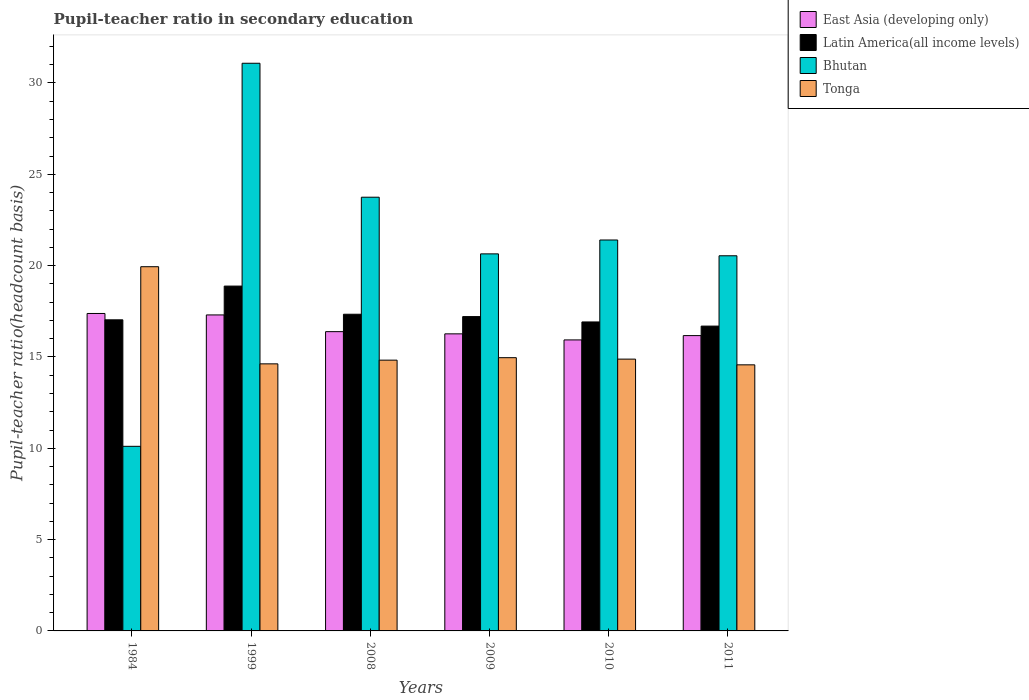How many different coloured bars are there?
Make the answer very short. 4. Are the number of bars on each tick of the X-axis equal?
Offer a terse response. Yes. What is the label of the 6th group of bars from the left?
Make the answer very short. 2011. In how many cases, is the number of bars for a given year not equal to the number of legend labels?
Your answer should be compact. 0. What is the pupil-teacher ratio in secondary education in Tonga in 1984?
Give a very brief answer. 19.94. Across all years, what is the maximum pupil-teacher ratio in secondary education in Latin America(all income levels)?
Ensure brevity in your answer.  18.88. Across all years, what is the minimum pupil-teacher ratio in secondary education in Bhutan?
Your answer should be very brief. 10.11. In which year was the pupil-teacher ratio in secondary education in Latin America(all income levels) maximum?
Offer a very short reply. 1999. What is the total pupil-teacher ratio in secondary education in Latin America(all income levels) in the graph?
Give a very brief answer. 104.07. What is the difference between the pupil-teacher ratio in secondary education in Tonga in 1984 and that in 1999?
Keep it short and to the point. 5.32. What is the difference between the pupil-teacher ratio in secondary education in Tonga in 2010 and the pupil-teacher ratio in secondary education in Latin America(all income levels) in 1999?
Keep it short and to the point. -4. What is the average pupil-teacher ratio in secondary education in Bhutan per year?
Your answer should be compact. 21.25. In the year 1984, what is the difference between the pupil-teacher ratio in secondary education in Bhutan and pupil-teacher ratio in secondary education in East Asia (developing only)?
Offer a terse response. -7.27. In how many years, is the pupil-teacher ratio in secondary education in Tonga greater than 6?
Your response must be concise. 6. What is the ratio of the pupil-teacher ratio in secondary education in East Asia (developing only) in 2009 to that in 2011?
Provide a succinct answer. 1.01. Is the pupil-teacher ratio in secondary education in Tonga in 2008 less than that in 2010?
Provide a short and direct response. Yes. What is the difference between the highest and the second highest pupil-teacher ratio in secondary education in Latin America(all income levels)?
Offer a very short reply. 1.54. What is the difference between the highest and the lowest pupil-teacher ratio in secondary education in Tonga?
Your response must be concise. 5.37. In how many years, is the pupil-teacher ratio in secondary education in East Asia (developing only) greater than the average pupil-teacher ratio in secondary education in East Asia (developing only) taken over all years?
Your response must be concise. 2. Is it the case that in every year, the sum of the pupil-teacher ratio in secondary education in East Asia (developing only) and pupil-teacher ratio in secondary education in Bhutan is greater than the sum of pupil-teacher ratio in secondary education in Tonga and pupil-teacher ratio in secondary education in Latin America(all income levels)?
Provide a short and direct response. No. What does the 4th bar from the left in 2009 represents?
Make the answer very short. Tonga. What does the 3rd bar from the right in 1984 represents?
Offer a very short reply. Latin America(all income levels). Is it the case that in every year, the sum of the pupil-teacher ratio in secondary education in Latin America(all income levels) and pupil-teacher ratio in secondary education in Tonga is greater than the pupil-teacher ratio in secondary education in East Asia (developing only)?
Ensure brevity in your answer.  Yes. Are all the bars in the graph horizontal?
Your response must be concise. No. What is the difference between two consecutive major ticks on the Y-axis?
Provide a short and direct response. 5. Does the graph contain any zero values?
Make the answer very short. No. Does the graph contain grids?
Your response must be concise. No. How many legend labels are there?
Make the answer very short. 4. How are the legend labels stacked?
Your answer should be compact. Vertical. What is the title of the graph?
Ensure brevity in your answer.  Pupil-teacher ratio in secondary education. What is the label or title of the Y-axis?
Ensure brevity in your answer.  Pupil-teacher ratio(headcount basis). What is the Pupil-teacher ratio(headcount basis) in East Asia (developing only) in 1984?
Ensure brevity in your answer.  17.38. What is the Pupil-teacher ratio(headcount basis) in Latin America(all income levels) in 1984?
Give a very brief answer. 17.03. What is the Pupil-teacher ratio(headcount basis) of Bhutan in 1984?
Provide a short and direct response. 10.11. What is the Pupil-teacher ratio(headcount basis) in Tonga in 1984?
Your answer should be very brief. 19.94. What is the Pupil-teacher ratio(headcount basis) of East Asia (developing only) in 1999?
Your answer should be very brief. 17.3. What is the Pupil-teacher ratio(headcount basis) of Latin America(all income levels) in 1999?
Make the answer very short. 18.88. What is the Pupil-teacher ratio(headcount basis) in Bhutan in 1999?
Give a very brief answer. 31.08. What is the Pupil-teacher ratio(headcount basis) of Tonga in 1999?
Offer a very short reply. 14.62. What is the Pupil-teacher ratio(headcount basis) of East Asia (developing only) in 2008?
Provide a succinct answer. 16.38. What is the Pupil-teacher ratio(headcount basis) of Latin America(all income levels) in 2008?
Provide a short and direct response. 17.34. What is the Pupil-teacher ratio(headcount basis) in Bhutan in 2008?
Keep it short and to the point. 23.75. What is the Pupil-teacher ratio(headcount basis) in Tonga in 2008?
Give a very brief answer. 14.82. What is the Pupil-teacher ratio(headcount basis) of East Asia (developing only) in 2009?
Provide a short and direct response. 16.26. What is the Pupil-teacher ratio(headcount basis) in Latin America(all income levels) in 2009?
Your answer should be very brief. 17.21. What is the Pupil-teacher ratio(headcount basis) of Bhutan in 2009?
Make the answer very short. 20.64. What is the Pupil-teacher ratio(headcount basis) in Tonga in 2009?
Make the answer very short. 14.96. What is the Pupil-teacher ratio(headcount basis) of East Asia (developing only) in 2010?
Provide a short and direct response. 15.93. What is the Pupil-teacher ratio(headcount basis) of Latin America(all income levels) in 2010?
Ensure brevity in your answer.  16.92. What is the Pupil-teacher ratio(headcount basis) in Bhutan in 2010?
Make the answer very short. 21.4. What is the Pupil-teacher ratio(headcount basis) of Tonga in 2010?
Give a very brief answer. 14.88. What is the Pupil-teacher ratio(headcount basis) of East Asia (developing only) in 2011?
Offer a very short reply. 16.17. What is the Pupil-teacher ratio(headcount basis) of Latin America(all income levels) in 2011?
Give a very brief answer. 16.69. What is the Pupil-teacher ratio(headcount basis) of Bhutan in 2011?
Provide a short and direct response. 20.54. What is the Pupil-teacher ratio(headcount basis) of Tonga in 2011?
Keep it short and to the point. 14.57. Across all years, what is the maximum Pupil-teacher ratio(headcount basis) in East Asia (developing only)?
Make the answer very short. 17.38. Across all years, what is the maximum Pupil-teacher ratio(headcount basis) of Latin America(all income levels)?
Keep it short and to the point. 18.88. Across all years, what is the maximum Pupil-teacher ratio(headcount basis) in Bhutan?
Offer a very short reply. 31.08. Across all years, what is the maximum Pupil-teacher ratio(headcount basis) in Tonga?
Make the answer very short. 19.94. Across all years, what is the minimum Pupil-teacher ratio(headcount basis) of East Asia (developing only)?
Your response must be concise. 15.93. Across all years, what is the minimum Pupil-teacher ratio(headcount basis) in Latin America(all income levels)?
Your answer should be very brief. 16.69. Across all years, what is the minimum Pupil-teacher ratio(headcount basis) in Bhutan?
Give a very brief answer. 10.11. Across all years, what is the minimum Pupil-teacher ratio(headcount basis) of Tonga?
Provide a short and direct response. 14.57. What is the total Pupil-teacher ratio(headcount basis) of East Asia (developing only) in the graph?
Offer a very short reply. 99.43. What is the total Pupil-teacher ratio(headcount basis) in Latin America(all income levels) in the graph?
Your response must be concise. 104.07. What is the total Pupil-teacher ratio(headcount basis) of Bhutan in the graph?
Ensure brevity in your answer.  127.52. What is the total Pupil-teacher ratio(headcount basis) in Tonga in the graph?
Provide a succinct answer. 93.8. What is the difference between the Pupil-teacher ratio(headcount basis) in East Asia (developing only) in 1984 and that in 1999?
Offer a terse response. 0.08. What is the difference between the Pupil-teacher ratio(headcount basis) in Latin America(all income levels) in 1984 and that in 1999?
Your response must be concise. -1.85. What is the difference between the Pupil-teacher ratio(headcount basis) of Bhutan in 1984 and that in 1999?
Your answer should be very brief. -20.97. What is the difference between the Pupil-teacher ratio(headcount basis) of Tonga in 1984 and that in 1999?
Offer a terse response. 5.32. What is the difference between the Pupil-teacher ratio(headcount basis) of East Asia (developing only) in 1984 and that in 2008?
Ensure brevity in your answer.  1. What is the difference between the Pupil-teacher ratio(headcount basis) of Latin America(all income levels) in 1984 and that in 2008?
Your answer should be compact. -0.31. What is the difference between the Pupil-teacher ratio(headcount basis) of Bhutan in 1984 and that in 2008?
Give a very brief answer. -13.64. What is the difference between the Pupil-teacher ratio(headcount basis) in Tonga in 1984 and that in 2008?
Provide a succinct answer. 5.12. What is the difference between the Pupil-teacher ratio(headcount basis) in East Asia (developing only) in 1984 and that in 2009?
Offer a terse response. 1.12. What is the difference between the Pupil-teacher ratio(headcount basis) in Latin America(all income levels) in 1984 and that in 2009?
Your response must be concise. -0.18. What is the difference between the Pupil-teacher ratio(headcount basis) in Bhutan in 1984 and that in 2009?
Your response must be concise. -10.54. What is the difference between the Pupil-teacher ratio(headcount basis) of Tonga in 1984 and that in 2009?
Offer a very short reply. 4.98. What is the difference between the Pupil-teacher ratio(headcount basis) in East Asia (developing only) in 1984 and that in 2010?
Provide a short and direct response. 1.45. What is the difference between the Pupil-teacher ratio(headcount basis) of Latin America(all income levels) in 1984 and that in 2010?
Keep it short and to the point. 0.12. What is the difference between the Pupil-teacher ratio(headcount basis) in Bhutan in 1984 and that in 2010?
Your answer should be very brief. -11.3. What is the difference between the Pupil-teacher ratio(headcount basis) of Tonga in 1984 and that in 2010?
Provide a succinct answer. 5.06. What is the difference between the Pupil-teacher ratio(headcount basis) of East Asia (developing only) in 1984 and that in 2011?
Provide a succinct answer. 1.21. What is the difference between the Pupil-teacher ratio(headcount basis) in Latin America(all income levels) in 1984 and that in 2011?
Provide a short and direct response. 0.34. What is the difference between the Pupil-teacher ratio(headcount basis) of Bhutan in 1984 and that in 2011?
Give a very brief answer. -10.43. What is the difference between the Pupil-teacher ratio(headcount basis) of Tonga in 1984 and that in 2011?
Give a very brief answer. 5.37. What is the difference between the Pupil-teacher ratio(headcount basis) of East Asia (developing only) in 1999 and that in 2008?
Offer a terse response. 0.92. What is the difference between the Pupil-teacher ratio(headcount basis) of Latin America(all income levels) in 1999 and that in 2008?
Provide a succinct answer. 1.54. What is the difference between the Pupil-teacher ratio(headcount basis) of Bhutan in 1999 and that in 2008?
Provide a succinct answer. 7.33. What is the difference between the Pupil-teacher ratio(headcount basis) of Tonga in 1999 and that in 2008?
Your answer should be very brief. -0.2. What is the difference between the Pupil-teacher ratio(headcount basis) in East Asia (developing only) in 1999 and that in 2009?
Give a very brief answer. 1.04. What is the difference between the Pupil-teacher ratio(headcount basis) of Latin America(all income levels) in 1999 and that in 2009?
Give a very brief answer. 1.67. What is the difference between the Pupil-teacher ratio(headcount basis) of Bhutan in 1999 and that in 2009?
Ensure brevity in your answer.  10.44. What is the difference between the Pupil-teacher ratio(headcount basis) in Tonga in 1999 and that in 2009?
Offer a terse response. -0.34. What is the difference between the Pupil-teacher ratio(headcount basis) in East Asia (developing only) in 1999 and that in 2010?
Keep it short and to the point. 1.37. What is the difference between the Pupil-teacher ratio(headcount basis) of Latin America(all income levels) in 1999 and that in 2010?
Offer a very short reply. 1.96. What is the difference between the Pupil-teacher ratio(headcount basis) of Bhutan in 1999 and that in 2010?
Your answer should be compact. 9.68. What is the difference between the Pupil-teacher ratio(headcount basis) of Tonga in 1999 and that in 2010?
Your answer should be compact. -0.26. What is the difference between the Pupil-teacher ratio(headcount basis) of East Asia (developing only) in 1999 and that in 2011?
Your answer should be very brief. 1.13. What is the difference between the Pupil-teacher ratio(headcount basis) in Latin America(all income levels) in 1999 and that in 2011?
Provide a short and direct response. 2.19. What is the difference between the Pupil-teacher ratio(headcount basis) in Bhutan in 1999 and that in 2011?
Make the answer very short. 10.54. What is the difference between the Pupil-teacher ratio(headcount basis) of Tonga in 1999 and that in 2011?
Offer a terse response. 0.05. What is the difference between the Pupil-teacher ratio(headcount basis) of East Asia (developing only) in 2008 and that in 2009?
Your answer should be very brief. 0.12. What is the difference between the Pupil-teacher ratio(headcount basis) of Latin America(all income levels) in 2008 and that in 2009?
Give a very brief answer. 0.13. What is the difference between the Pupil-teacher ratio(headcount basis) of Bhutan in 2008 and that in 2009?
Give a very brief answer. 3.1. What is the difference between the Pupil-teacher ratio(headcount basis) of Tonga in 2008 and that in 2009?
Make the answer very short. -0.14. What is the difference between the Pupil-teacher ratio(headcount basis) of East Asia (developing only) in 2008 and that in 2010?
Keep it short and to the point. 0.45. What is the difference between the Pupil-teacher ratio(headcount basis) in Latin America(all income levels) in 2008 and that in 2010?
Keep it short and to the point. 0.42. What is the difference between the Pupil-teacher ratio(headcount basis) of Bhutan in 2008 and that in 2010?
Your response must be concise. 2.34. What is the difference between the Pupil-teacher ratio(headcount basis) of Tonga in 2008 and that in 2010?
Offer a terse response. -0.06. What is the difference between the Pupil-teacher ratio(headcount basis) in East Asia (developing only) in 2008 and that in 2011?
Provide a succinct answer. 0.22. What is the difference between the Pupil-teacher ratio(headcount basis) of Latin America(all income levels) in 2008 and that in 2011?
Provide a short and direct response. 0.65. What is the difference between the Pupil-teacher ratio(headcount basis) in Bhutan in 2008 and that in 2011?
Your answer should be compact. 3.21. What is the difference between the Pupil-teacher ratio(headcount basis) of Tonga in 2008 and that in 2011?
Offer a terse response. 0.26. What is the difference between the Pupil-teacher ratio(headcount basis) in East Asia (developing only) in 2009 and that in 2010?
Ensure brevity in your answer.  0.33. What is the difference between the Pupil-teacher ratio(headcount basis) in Latin America(all income levels) in 2009 and that in 2010?
Ensure brevity in your answer.  0.29. What is the difference between the Pupil-teacher ratio(headcount basis) of Bhutan in 2009 and that in 2010?
Provide a succinct answer. -0.76. What is the difference between the Pupil-teacher ratio(headcount basis) of Tonga in 2009 and that in 2010?
Offer a terse response. 0.08. What is the difference between the Pupil-teacher ratio(headcount basis) in East Asia (developing only) in 2009 and that in 2011?
Your response must be concise. 0.1. What is the difference between the Pupil-teacher ratio(headcount basis) in Latin America(all income levels) in 2009 and that in 2011?
Make the answer very short. 0.52. What is the difference between the Pupil-teacher ratio(headcount basis) in Bhutan in 2009 and that in 2011?
Your answer should be compact. 0.1. What is the difference between the Pupil-teacher ratio(headcount basis) of Tonga in 2009 and that in 2011?
Ensure brevity in your answer.  0.39. What is the difference between the Pupil-teacher ratio(headcount basis) of East Asia (developing only) in 2010 and that in 2011?
Give a very brief answer. -0.24. What is the difference between the Pupil-teacher ratio(headcount basis) in Latin America(all income levels) in 2010 and that in 2011?
Ensure brevity in your answer.  0.23. What is the difference between the Pupil-teacher ratio(headcount basis) in Bhutan in 2010 and that in 2011?
Offer a very short reply. 0.86. What is the difference between the Pupil-teacher ratio(headcount basis) of Tonga in 2010 and that in 2011?
Provide a succinct answer. 0.31. What is the difference between the Pupil-teacher ratio(headcount basis) in East Asia (developing only) in 1984 and the Pupil-teacher ratio(headcount basis) in Latin America(all income levels) in 1999?
Offer a very short reply. -1.5. What is the difference between the Pupil-teacher ratio(headcount basis) of East Asia (developing only) in 1984 and the Pupil-teacher ratio(headcount basis) of Bhutan in 1999?
Offer a very short reply. -13.7. What is the difference between the Pupil-teacher ratio(headcount basis) of East Asia (developing only) in 1984 and the Pupil-teacher ratio(headcount basis) of Tonga in 1999?
Your answer should be very brief. 2.76. What is the difference between the Pupil-teacher ratio(headcount basis) of Latin America(all income levels) in 1984 and the Pupil-teacher ratio(headcount basis) of Bhutan in 1999?
Offer a very short reply. -14.05. What is the difference between the Pupil-teacher ratio(headcount basis) in Latin America(all income levels) in 1984 and the Pupil-teacher ratio(headcount basis) in Tonga in 1999?
Make the answer very short. 2.41. What is the difference between the Pupil-teacher ratio(headcount basis) of Bhutan in 1984 and the Pupil-teacher ratio(headcount basis) of Tonga in 1999?
Keep it short and to the point. -4.52. What is the difference between the Pupil-teacher ratio(headcount basis) in East Asia (developing only) in 1984 and the Pupil-teacher ratio(headcount basis) in Latin America(all income levels) in 2008?
Your answer should be compact. 0.04. What is the difference between the Pupil-teacher ratio(headcount basis) in East Asia (developing only) in 1984 and the Pupil-teacher ratio(headcount basis) in Bhutan in 2008?
Ensure brevity in your answer.  -6.37. What is the difference between the Pupil-teacher ratio(headcount basis) in East Asia (developing only) in 1984 and the Pupil-teacher ratio(headcount basis) in Tonga in 2008?
Your answer should be compact. 2.56. What is the difference between the Pupil-teacher ratio(headcount basis) of Latin America(all income levels) in 1984 and the Pupil-teacher ratio(headcount basis) of Bhutan in 2008?
Your answer should be very brief. -6.71. What is the difference between the Pupil-teacher ratio(headcount basis) in Latin America(all income levels) in 1984 and the Pupil-teacher ratio(headcount basis) in Tonga in 2008?
Keep it short and to the point. 2.21. What is the difference between the Pupil-teacher ratio(headcount basis) of Bhutan in 1984 and the Pupil-teacher ratio(headcount basis) of Tonga in 2008?
Offer a terse response. -4.72. What is the difference between the Pupil-teacher ratio(headcount basis) of East Asia (developing only) in 1984 and the Pupil-teacher ratio(headcount basis) of Latin America(all income levels) in 2009?
Your response must be concise. 0.17. What is the difference between the Pupil-teacher ratio(headcount basis) in East Asia (developing only) in 1984 and the Pupil-teacher ratio(headcount basis) in Bhutan in 2009?
Offer a terse response. -3.26. What is the difference between the Pupil-teacher ratio(headcount basis) of East Asia (developing only) in 1984 and the Pupil-teacher ratio(headcount basis) of Tonga in 2009?
Ensure brevity in your answer.  2.42. What is the difference between the Pupil-teacher ratio(headcount basis) in Latin America(all income levels) in 1984 and the Pupil-teacher ratio(headcount basis) in Bhutan in 2009?
Your response must be concise. -3.61. What is the difference between the Pupil-teacher ratio(headcount basis) in Latin America(all income levels) in 1984 and the Pupil-teacher ratio(headcount basis) in Tonga in 2009?
Make the answer very short. 2.07. What is the difference between the Pupil-teacher ratio(headcount basis) of Bhutan in 1984 and the Pupil-teacher ratio(headcount basis) of Tonga in 2009?
Provide a short and direct response. -4.85. What is the difference between the Pupil-teacher ratio(headcount basis) of East Asia (developing only) in 1984 and the Pupil-teacher ratio(headcount basis) of Latin America(all income levels) in 2010?
Give a very brief answer. 0.46. What is the difference between the Pupil-teacher ratio(headcount basis) of East Asia (developing only) in 1984 and the Pupil-teacher ratio(headcount basis) of Bhutan in 2010?
Give a very brief answer. -4.02. What is the difference between the Pupil-teacher ratio(headcount basis) of East Asia (developing only) in 1984 and the Pupil-teacher ratio(headcount basis) of Tonga in 2010?
Make the answer very short. 2.5. What is the difference between the Pupil-teacher ratio(headcount basis) in Latin America(all income levels) in 1984 and the Pupil-teacher ratio(headcount basis) in Bhutan in 2010?
Provide a short and direct response. -4.37. What is the difference between the Pupil-teacher ratio(headcount basis) of Latin America(all income levels) in 1984 and the Pupil-teacher ratio(headcount basis) of Tonga in 2010?
Offer a terse response. 2.15. What is the difference between the Pupil-teacher ratio(headcount basis) in Bhutan in 1984 and the Pupil-teacher ratio(headcount basis) in Tonga in 2010?
Ensure brevity in your answer.  -4.77. What is the difference between the Pupil-teacher ratio(headcount basis) in East Asia (developing only) in 1984 and the Pupil-teacher ratio(headcount basis) in Latin America(all income levels) in 2011?
Your answer should be compact. 0.69. What is the difference between the Pupil-teacher ratio(headcount basis) in East Asia (developing only) in 1984 and the Pupil-teacher ratio(headcount basis) in Bhutan in 2011?
Give a very brief answer. -3.16. What is the difference between the Pupil-teacher ratio(headcount basis) of East Asia (developing only) in 1984 and the Pupil-teacher ratio(headcount basis) of Tonga in 2011?
Offer a very short reply. 2.81. What is the difference between the Pupil-teacher ratio(headcount basis) of Latin America(all income levels) in 1984 and the Pupil-teacher ratio(headcount basis) of Bhutan in 2011?
Offer a terse response. -3.51. What is the difference between the Pupil-teacher ratio(headcount basis) in Latin America(all income levels) in 1984 and the Pupil-teacher ratio(headcount basis) in Tonga in 2011?
Offer a terse response. 2.46. What is the difference between the Pupil-teacher ratio(headcount basis) of Bhutan in 1984 and the Pupil-teacher ratio(headcount basis) of Tonga in 2011?
Your answer should be very brief. -4.46. What is the difference between the Pupil-teacher ratio(headcount basis) in East Asia (developing only) in 1999 and the Pupil-teacher ratio(headcount basis) in Latin America(all income levels) in 2008?
Give a very brief answer. -0.04. What is the difference between the Pupil-teacher ratio(headcount basis) in East Asia (developing only) in 1999 and the Pupil-teacher ratio(headcount basis) in Bhutan in 2008?
Give a very brief answer. -6.45. What is the difference between the Pupil-teacher ratio(headcount basis) in East Asia (developing only) in 1999 and the Pupil-teacher ratio(headcount basis) in Tonga in 2008?
Offer a terse response. 2.48. What is the difference between the Pupil-teacher ratio(headcount basis) in Latin America(all income levels) in 1999 and the Pupil-teacher ratio(headcount basis) in Bhutan in 2008?
Give a very brief answer. -4.87. What is the difference between the Pupil-teacher ratio(headcount basis) in Latin America(all income levels) in 1999 and the Pupil-teacher ratio(headcount basis) in Tonga in 2008?
Make the answer very short. 4.05. What is the difference between the Pupil-teacher ratio(headcount basis) in Bhutan in 1999 and the Pupil-teacher ratio(headcount basis) in Tonga in 2008?
Offer a terse response. 16.25. What is the difference between the Pupil-teacher ratio(headcount basis) of East Asia (developing only) in 1999 and the Pupil-teacher ratio(headcount basis) of Latin America(all income levels) in 2009?
Keep it short and to the point. 0.09. What is the difference between the Pupil-teacher ratio(headcount basis) in East Asia (developing only) in 1999 and the Pupil-teacher ratio(headcount basis) in Bhutan in 2009?
Your answer should be very brief. -3.34. What is the difference between the Pupil-teacher ratio(headcount basis) of East Asia (developing only) in 1999 and the Pupil-teacher ratio(headcount basis) of Tonga in 2009?
Ensure brevity in your answer.  2.34. What is the difference between the Pupil-teacher ratio(headcount basis) of Latin America(all income levels) in 1999 and the Pupil-teacher ratio(headcount basis) of Bhutan in 2009?
Provide a succinct answer. -1.76. What is the difference between the Pupil-teacher ratio(headcount basis) in Latin America(all income levels) in 1999 and the Pupil-teacher ratio(headcount basis) in Tonga in 2009?
Your response must be concise. 3.92. What is the difference between the Pupil-teacher ratio(headcount basis) of Bhutan in 1999 and the Pupil-teacher ratio(headcount basis) of Tonga in 2009?
Offer a very short reply. 16.12. What is the difference between the Pupil-teacher ratio(headcount basis) of East Asia (developing only) in 1999 and the Pupil-teacher ratio(headcount basis) of Latin America(all income levels) in 2010?
Give a very brief answer. 0.38. What is the difference between the Pupil-teacher ratio(headcount basis) of East Asia (developing only) in 1999 and the Pupil-teacher ratio(headcount basis) of Bhutan in 2010?
Give a very brief answer. -4.1. What is the difference between the Pupil-teacher ratio(headcount basis) in East Asia (developing only) in 1999 and the Pupil-teacher ratio(headcount basis) in Tonga in 2010?
Provide a short and direct response. 2.42. What is the difference between the Pupil-teacher ratio(headcount basis) of Latin America(all income levels) in 1999 and the Pupil-teacher ratio(headcount basis) of Bhutan in 2010?
Provide a short and direct response. -2.52. What is the difference between the Pupil-teacher ratio(headcount basis) of Latin America(all income levels) in 1999 and the Pupil-teacher ratio(headcount basis) of Tonga in 2010?
Ensure brevity in your answer.  4. What is the difference between the Pupil-teacher ratio(headcount basis) in Bhutan in 1999 and the Pupil-teacher ratio(headcount basis) in Tonga in 2010?
Provide a short and direct response. 16.2. What is the difference between the Pupil-teacher ratio(headcount basis) of East Asia (developing only) in 1999 and the Pupil-teacher ratio(headcount basis) of Latin America(all income levels) in 2011?
Keep it short and to the point. 0.61. What is the difference between the Pupil-teacher ratio(headcount basis) in East Asia (developing only) in 1999 and the Pupil-teacher ratio(headcount basis) in Bhutan in 2011?
Offer a very short reply. -3.24. What is the difference between the Pupil-teacher ratio(headcount basis) of East Asia (developing only) in 1999 and the Pupil-teacher ratio(headcount basis) of Tonga in 2011?
Offer a terse response. 2.73. What is the difference between the Pupil-teacher ratio(headcount basis) in Latin America(all income levels) in 1999 and the Pupil-teacher ratio(headcount basis) in Bhutan in 2011?
Make the answer very short. -1.66. What is the difference between the Pupil-teacher ratio(headcount basis) of Latin America(all income levels) in 1999 and the Pupil-teacher ratio(headcount basis) of Tonga in 2011?
Your answer should be very brief. 4.31. What is the difference between the Pupil-teacher ratio(headcount basis) in Bhutan in 1999 and the Pupil-teacher ratio(headcount basis) in Tonga in 2011?
Your answer should be very brief. 16.51. What is the difference between the Pupil-teacher ratio(headcount basis) in East Asia (developing only) in 2008 and the Pupil-teacher ratio(headcount basis) in Latin America(all income levels) in 2009?
Offer a terse response. -0.82. What is the difference between the Pupil-teacher ratio(headcount basis) in East Asia (developing only) in 2008 and the Pupil-teacher ratio(headcount basis) in Bhutan in 2009?
Your response must be concise. -4.26. What is the difference between the Pupil-teacher ratio(headcount basis) in East Asia (developing only) in 2008 and the Pupil-teacher ratio(headcount basis) in Tonga in 2009?
Your answer should be compact. 1.42. What is the difference between the Pupil-teacher ratio(headcount basis) in Latin America(all income levels) in 2008 and the Pupil-teacher ratio(headcount basis) in Bhutan in 2009?
Give a very brief answer. -3.31. What is the difference between the Pupil-teacher ratio(headcount basis) of Latin America(all income levels) in 2008 and the Pupil-teacher ratio(headcount basis) of Tonga in 2009?
Make the answer very short. 2.38. What is the difference between the Pupil-teacher ratio(headcount basis) in Bhutan in 2008 and the Pupil-teacher ratio(headcount basis) in Tonga in 2009?
Your answer should be compact. 8.79. What is the difference between the Pupil-teacher ratio(headcount basis) in East Asia (developing only) in 2008 and the Pupil-teacher ratio(headcount basis) in Latin America(all income levels) in 2010?
Your response must be concise. -0.53. What is the difference between the Pupil-teacher ratio(headcount basis) in East Asia (developing only) in 2008 and the Pupil-teacher ratio(headcount basis) in Bhutan in 2010?
Your answer should be very brief. -5.02. What is the difference between the Pupil-teacher ratio(headcount basis) of East Asia (developing only) in 2008 and the Pupil-teacher ratio(headcount basis) of Tonga in 2010?
Ensure brevity in your answer.  1.5. What is the difference between the Pupil-teacher ratio(headcount basis) of Latin America(all income levels) in 2008 and the Pupil-teacher ratio(headcount basis) of Bhutan in 2010?
Your answer should be compact. -4.07. What is the difference between the Pupil-teacher ratio(headcount basis) of Latin America(all income levels) in 2008 and the Pupil-teacher ratio(headcount basis) of Tonga in 2010?
Keep it short and to the point. 2.46. What is the difference between the Pupil-teacher ratio(headcount basis) of Bhutan in 2008 and the Pupil-teacher ratio(headcount basis) of Tonga in 2010?
Provide a short and direct response. 8.86. What is the difference between the Pupil-teacher ratio(headcount basis) of East Asia (developing only) in 2008 and the Pupil-teacher ratio(headcount basis) of Latin America(all income levels) in 2011?
Offer a terse response. -0.3. What is the difference between the Pupil-teacher ratio(headcount basis) of East Asia (developing only) in 2008 and the Pupil-teacher ratio(headcount basis) of Bhutan in 2011?
Keep it short and to the point. -4.15. What is the difference between the Pupil-teacher ratio(headcount basis) of East Asia (developing only) in 2008 and the Pupil-teacher ratio(headcount basis) of Tonga in 2011?
Offer a very short reply. 1.82. What is the difference between the Pupil-teacher ratio(headcount basis) of Latin America(all income levels) in 2008 and the Pupil-teacher ratio(headcount basis) of Bhutan in 2011?
Your response must be concise. -3.2. What is the difference between the Pupil-teacher ratio(headcount basis) of Latin America(all income levels) in 2008 and the Pupil-teacher ratio(headcount basis) of Tonga in 2011?
Give a very brief answer. 2.77. What is the difference between the Pupil-teacher ratio(headcount basis) of Bhutan in 2008 and the Pupil-teacher ratio(headcount basis) of Tonga in 2011?
Your answer should be compact. 9.18. What is the difference between the Pupil-teacher ratio(headcount basis) in East Asia (developing only) in 2009 and the Pupil-teacher ratio(headcount basis) in Latin America(all income levels) in 2010?
Give a very brief answer. -0.65. What is the difference between the Pupil-teacher ratio(headcount basis) in East Asia (developing only) in 2009 and the Pupil-teacher ratio(headcount basis) in Bhutan in 2010?
Your response must be concise. -5.14. What is the difference between the Pupil-teacher ratio(headcount basis) of East Asia (developing only) in 2009 and the Pupil-teacher ratio(headcount basis) of Tonga in 2010?
Your answer should be very brief. 1.38. What is the difference between the Pupil-teacher ratio(headcount basis) of Latin America(all income levels) in 2009 and the Pupil-teacher ratio(headcount basis) of Bhutan in 2010?
Provide a succinct answer. -4.19. What is the difference between the Pupil-teacher ratio(headcount basis) of Latin America(all income levels) in 2009 and the Pupil-teacher ratio(headcount basis) of Tonga in 2010?
Offer a terse response. 2.33. What is the difference between the Pupil-teacher ratio(headcount basis) of Bhutan in 2009 and the Pupil-teacher ratio(headcount basis) of Tonga in 2010?
Provide a short and direct response. 5.76. What is the difference between the Pupil-teacher ratio(headcount basis) in East Asia (developing only) in 2009 and the Pupil-teacher ratio(headcount basis) in Latin America(all income levels) in 2011?
Offer a very short reply. -0.42. What is the difference between the Pupil-teacher ratio(headcount basis) of East Asia (developing only) in 2009 and the Pupil-teacher ratio(headcount basis) of Bhutan in 2011?
Keep it short and to the point. -4.27. What is the difference between the Pupil-teacher ratio(headcount basis) in East Asia (developing only) in 2009 and the Pupil-teacher ratio(headcount basis) in Tonga in 2011?
Provide a short and direct response. 1.7. What is the difference between the Pupil-teacher ratio(headcount basis) of Latin America(all income levels) in 2009 and the Pupil-teacher ratio(headcount basis) of Bhutan in 2011?
Offer a terse response. -3.33. What is the difference between the Pupil-teacher ratio(headcount basis) in Latin America(all income levels) in 2009 and the Pupil-teacher ratio(headcount basis) in Tonga in 2011?
Give a very brief answer. 2.64. What is the difference between the Pupil-teacher ratio(headcount basis) in Bhutan in 2009 and the Pupil-teacher ratio(headcount basis) in Tonga in 2011?
Ensure brevity in your answer.  6.08. What is the difference between the Pupil-teacher ratio(headcount basis) of East Asia (developing only) in 2010 and the Pupil-teacher ratio(headcount basis) of Latin America(all income levels) in 2011?
Give a very brief answer. -0.76. What is the difference between the Pupil-teacher ratio(headcount basis) of East Asia (developing only) in 2010 and the Pupil-teacher ratio(headcount basis) of Bhutan in 2011?
Make the answer very short. -4.61. What is the difference between the Pupil-teacher ratio(headcount basis) in East Asia (developing only) in 2010 and the Pupil-teacher ratio(headcount basis) in Tonga in 2011?
Keep it short and to the point. 1.36. What is the difference between the Pupil-teacher ratio(headcount basis) of Latin America(all income levels) in 2010 and the Pupil-teacher ratio(headcount basis) of Bhutan in 2011?
Your response must be concise. -3.62. What is the difference between the Pupil-teacher ratio(headcount basis) of Latin America(all income levels) in 2010 and the Pupil-teacher ratio(headcount basis) of Tonga in 2011?
Keep it short and to the point. 2.35. What is the difference between the Pupil-teacher ratio(headcount basis) of Bhutan in 2010 and the Pupil-teacher ratio(headcount basis) of Tonga in 2011?
Your answer should be compact. 6.84. What is the average Pupil-teacher ratio(headcount basis) in East Asia (developing only) per year?
Offer a terse response. 16.57. What is the average Pupil-teacher ratio(headcount basis) of Latin America(all income levels) per year?
Keep it short and to the point. 17.34. What is the average Pupil-teacher ratio(headcount basis) of Bhutan per year?
Provide a succinct answer. 21.25. What is the average Pupil-teacher ratio(headcount basis) of Tonga per year?
Keep it short and to the point. 15.63. In the year 1984, what is the difference between the Pupil-teacher ratio(headcount basis) of East Asia (developing only) and Pupil-teacher ratio(headcount basis) of Latin America(all income levels)?
Your answer should be very brief. 0.35. In the year 1984, what is the difference between the Pupil-teacher ratio(headcount basis) in East Asia (developing only) and Pupil-teacher ratio(headcount basis) in Bhutan?
Make the answer very short. 7.27. In the year 1984, what is the difference between the Pupil-teacher ratio(headcount basis) of East Asia (developing only) and Pupil-teacher ratio(headcount basis) of Tonga?
Provide a succinct answer. -2.56. In the year 1984, what is the difference between the Pupil-teacher ratio(headcount basis) of Latin America(all income levels) and Pupil-teacher ratio(headcount basis) of Bhutan?
Provide a short and direct response. 6.93. In the year 1984, what is the difference between the Pupil-teacher ratio(headcount basis) of Latin America(all income levels) and Pupil-teacher ratio(headcount basis) of Tonga?
Provide a short and direct response. -2.91. In the year 1984, what is the difference between the Pupil-teacher ratio(headcount basis) in Bhutan and Pupil-teacher ratio(headcount basis) in Tonga?
Keep it short and to the point. -9.83. In the year 1999, what is the difference between the Pupil-teacher ratio(headcount basis) in East Asia (developing only) and Pupil-teacher ratio(headcount basis) in Latin America(all income levels)?
Provide a short and direct response. -1.58. In the year 1999, what is the difference between the Pupil-teacher ratio(headcount basis) in East Asia (developing only) and Pupil-teacher ratio(headcount basis) in Bhutan?
Provide a succinct answer. -13.78. In the year 1999, what is the difference between the Pupil-teacher ratio(headcount basis) in East Asia (developing only) and Pupil-teacher ratio(headcount basis) in Tonga?
Provide a succinct answer. 2.68. In the year 1999, what is the difference between the Pupil-teacher ratio(headcount basis) of Latin America(all income levels) and Pupil-teacher ratio(headcount basis) of Bhutan?
Make the answer very short. -12.2. In the year 1999, what is the difference between the Pupil-teacher ratio(headcount basis) of Latin America(all income levels) and Pupil-teacher ratio(headcount basis) of Tonga?
Give a very brief answer. 4.26. In the year 1999, what is the difference between the Pupil-teacher ratio(headcount basis) of Bhutan and Pupil-teacher ratio(headcount basis) of Tonga?
Provide a succinct answer. 16.46. In the year 2008, what is the difference between the Pupil-teacher ratio(headcount basis) in East Asia (developing only) and Pupil-teacher ratio(headcount basis) in Latin America(all income levels)?
Your answer should be compact. -0.95. In the year 2008, what is the difference between the Pupil-teacher ratio(headcount basis) in East Asia (developing only) and Pupil-teacher ratio(headcount basis) in Bhutan?
Ensure brevity in your answer.  -7.36. In the year 2008, what is the difference between the Pupil-teacher ratio(headcount basis) in East Asia (developing only) and Pupil-teacher ratio(headcount basis) in Tonga?
Give a very brief answer. 1.56. In the year 2008, what is the difference between the Pupil-teacher ratio(headcount basis) in Latin America(all income levels) and Pupil-teacher ratio(headcount basis) in Bhutan?
Your answer should be very brief. -6.41. In the year 2008, what is the difference between the Pupil-teacher ratio(headcount basis) in Latin America(all income levels) and Pupil-teacher ratio(headcount basis) in Tonga?
Keep it short and to the point. 2.51. In the year 2008, what is the difference between the Pupil-teacher ratio(headcount basis) of Bhutan and Pupil-teacher ratio(headcount basis) of Tonga?
Your answer should be very brief. 8.92. In the year 2009, what is the difference between the Pupil-teacher ratio(headcount basis) in East Asia (developing only) and Pupil-teacher ratio(headcount basis) in Latin America(all income levels)?
Provide a succinct answer. -0.94. In the year 2009, what is the difference between the Pupil-teacher ratio(headcount basis) of East Asia (developing only) and Pupil-teacher ratio(headcount basis) of Bhutan?
Your answer should be very brief. -4.38. In the year 2009, what is the difference between the Pupil-teacher ratio(headcount basis) of East Asia (developing only) and Pupil-teacher ratio(headcount basis) of Tonga?
Provide a short and direct response. 1.3. In the year 2009, what is the difference between the Pupil-teacher ratio(headcount basis) of Latin America(all income levels) and Pupil-teacher ratio(headcount basis) of Bhutan?
Keep it short and to the point. -3.43. In the year 2009, what is the difference between the Pupil-teacher ratio(headcount basis) of Latin America(all income levels) and Pupil-teacher ratio(headcount basis) of Tonga?
Your response must be concise. 2.25. In the year 2009, what is the difference between the Pupil-teacher ratio(headcount basis) of Bhutan and Pupil-teacher ratio(headcount basis) of Tonga?
Offer a very short reply. 5.68. In the year 2010, what is the difference between the Pupil-teacher ratio(headcount basis) in East Asia (developing only) and Pupil-teacher ratio(headcount basis) in Latin America(all income levels)?
Your answer should be very brief. -0.98. In the year 2010, what is the difference between the Pupil-teacher ratio(headcount basis) of East Asia (developing only) and Pupil-teacher ratio(headcount basis) of Bhutan?
Make the answer very short. -5.47. In the year 2010, what is the difference between the Pupil-teacher ratio(headcount basis) of East Asia (developing only) and Pupil-teacher ratio(headcount basis) of Tonga?
Offer a terse response. 1.05. In the year 2010, what is the difference between the Pupil-teacher ratio(headcount basis) of Latin America(all income levels) and Pupil-teacher ratio(headcount basis) of Bhutan?
Offer a terse response. -4.49. In the year 2010, what is the difference between the Pupil-teacher ratio(headcount basis) of Latin America(all income levels) and Pupil-teacher ratio(headcount basis) of Tonga?
Keep it short and to the point. 2.04. In the year 2010, what is the difference between the Pupil-teacher ratio(headcount basis) of Bhutan and Pupil-teacher ratio(headcount basis) of Tonga?
Offer a very short reply. 6.52. In the year 2011, what is the difference between the Pupil-teacher ratio(headcount basis) in East Asia (developing only) and Pupil-teacher ratio(headcount basis) in Latin America(all income levels)?
Make the answer very short. -0.52. In the year 2011, what is the difference between the Pupil-teacher ratio(headcount basis) in East Asia (developing only) and Pupil-teacher ratio(headcount basis) in Bhutan?
Make the answer very short. -4.37. In the year 2011, what is the difference between the Pupil-teacher ratio(headcount basis) of East Asia (developing only) and Pupil-teacher ratio(headcount basis) of Tonga?
Your answer should be very brief. 1.6. In the year 2011, what is the difference between the Pupil-teacher ratio(headcount basis) in Latin America(all income levels) and Pupil-teacher ratio(headcount basis) in Bhutan?
Provide a succinct answer. -3.85. In the year 2011, what is the difference between the Pupil-teacher ratio(headcount basis) in Latin America(all income levels) and Pupil-teacher ratio(headcount basis) in Tonga?
Make the answer very short. 2.12. In the year 2011, what is the difference between the Pupil-teacher ratio(headcount basis) of Bhutan and Pupil-teacher ratio(headcount basis) of Tonga?
Your answer should be very brief. 5.97. What is the ratio of the Pupil-teacher ratio(headcount basis) of East Asia (developing only) in 1984 to that in 1999?
Keep it short and to the point. 1. What is the ratio of the Pupil-teacher ratio(headcount basis) of Latin America(all income levels) in 1984 to that in 1999?
Your response must be concise. 0.9. What is the ratio of the Pupil-teacher ratio(headcount basis) in Bhutan in 1984 to that in 1999?
Provide a short and direct response. 0.33. What is the ratio of the Pupil-teacher ratio(headcount basis) in Tonga in 1984 to that in 1999?
Provide a short and direct response. 1.36. What is the ratio of the Pupil-teacher ratio(headcount basis) in East Asia (developing only) in 1984 to that in 2008?
Offer a terse response. 1.06. What is the ratio of the Pupil-teacher ratio(headcount basis) of Latin America(all income levels) in 1984 to that in 2008?
Your answer should be very brief. 0.98. What is the ratio of the Pupil-teacher ratio(headcount basis) of Bhutan in 1984 to that in 2008?
Make the answer very short. 0.43. What is the ratio of the Pupil-teacher ratio(headcount basis) in Tonga in 1984 to that in 2008?
Your answer should be compact. 1.35. What is the ratio of the Pupil-teacher ratio(headcount basis) in East Asia (developing only) in 1984 to that in 2009?
Give a very brief answer. 1.07. What is the ratio of the Pupil-teacher ratio(headcount basis) of Latin America(all income levels) in 1984 to that in 2009?
Your answer should be compact. 0.99. What is the ratio of the Pupil-teacher ratio(headcount basis) of Bhutan in 1984 to that in 2009?
Your response must be concise. 0.49. What is the ratio of the Pupil-teacher ratio(headcount basis) of Tonga in 1984 to that in 2009?
Keep it short and to the point. 1.33. What is the ratio of the Pupil-teacher ratio(headcount basis) in Bhutan in 1984 to that in 2010?
Offer a terse response. 0.47. What is the ratio of the Pupil-teacher ratio(headcount basis) in Tonga in 1984 to that in 2010?
Give a very brief answer. 1.34. What is the ratio of the Pupil-teacher ratio(headcount basis) of East Asia (developing only) in 1984 to that in 2011?
Keep it short and to the point. 1.07. What is the ratio of the Pupil-teacher ratio(headcount basis) in Latin America(all income levels) in 1984 to that in 2011?
Keep it short and to the point. 1.02. What is the ratio of the Pupil-teacher ratio(headcount basis) of Bhutan in 1984 to that in 2011?
Offer a terse response. 0.49. What is the ratio of the Pupil-teacher ratio(headcount basis) in Tonga in 1984 to that in 2011?
Ensure brevity in your answer.  1.37. What is the ratio of the Pupil-teacher ratio(headcount basis) of East Asia (developing only) in 1999 to that in 2008?
Make the answer very short. 1.06. What is the ratio of the Pupil-teacher ratio(headcount basis) in Latin America(all income levels) in 1999 to that in 2008?
Offer a terse response. 1.09. What is the ratio of the Pupil-teacher ratio(headcount basis) of Bhutan in 1999 to that in 2008?
Your answer should be compact. 1.31. What is the ratio of the Pupil-teacher ratio(headcount basis) in Tonga in 1999 to that in 2008?
Your response must be concise. 0.99. What is the ratio of the Pupil-teacher ratio(headcount basis) in East Asia (developing only) in 1999 to that in 2009?
Keep it short and to the point. 1.06. What is the ratio of the Pupil-teacher ratio(headcount basis) in Latin America(all income levels) in 1999 to that in 2009?
Your answer should be compact. 1.1. What is the ratio of the Pupil-teacher ratio(headcount basis) of Bhutan in 1999 to that in 2009?
Provide a succinct answer. 1.51. What is the ratio of the Pupil-teacher ratio(headcount basis) in Tonga in 1999 to that in 2009?
Give a very brief answer. 0.98. What is the ratio of the Pupil-teacher ratio(headcount basis) in East Asia (developing only) in 1999 to that in 2010?
Your answer should be very brief. 1.09. What is the ratio of the Pupil-teacher ratio(headcount basis) in Latin America(all income levels) in 1999 to that in 2010?
Offer a very short reply. 1.12. What is the ratio of the Pupil-teacher ratio(headcount basis) of Bhutan in 1999 to that in 2010?
Your response must be concise. 1.45. What is the ratio of the Pupil-teacher ratio(headcount basis) in Tonga in 1999 to that in 2010?
Offer a very short reply. 0.98. What is the ratio of the Pupil-teacher ratio(headcount basis) of East Asia (developing only) in 1999 to that in 2011?
Keep it short and to the point. 1.07. What is the ratio of the Pupil-teacher ratio(headcount basis) of Latin America(all income levels) in 1999 to that in 2011?
Your answer should be very brief. 1.13. What is the ratio of the Pupil-teacher ratio(headcount basis) in Bhutan in 1999 to that in 2011?
Make the answer very short. 1.51. What is the ratio of the Pupil-teacher ratio(headcount basis) of Tonga in 1999 to that in 2011?
Your answer should be compact. 1. What is the ratio of the Pupil-teacher ratio(headcount basis) in East Asia (developing only) in 2008 to that in 2009?
Provide a succinct answer. 1.01. What is the ratio of the Pupil-teacher ratio(headcount basis) of Latin America(all income levels) in 2008 to that in 2009?
Provide a succinct answer. 1.01. What is the ratio of the Pupil-teacher ratio(headcount basis) in Bhutan in 2008 to that in 2009?
Provide a short and direct response. 1.15. What is the ratio of the Pupil-teacher ratio(headcount basis) of Tonga in 2008 to that in 2009?
Give a very brief answer. 0.99. What is the ratio of the Pupil-teacher ratio(headcount basis) of East Asia (developing only) in 2008 to that in 2010?
Give a very brief answer. 1.03. What is the ratio of the Pupil-teacher ratio(headcount basis) of Latin America(all income levels) in 2008 to that in 2010?
Provide a succinct answer. 1.02. What is the ratio of the Pupil-teacher ratio(headcount basis) in Bhutan in 2008 to that in 2010?
Ensure brevity in your answer.  1.11. What is the ratio of the Pupil-teacher ratio(headcount basis) in East Asia (developing only) in 2008 to that in 2011?
Offer a terse response. 1.01. What is the ratio of the Pupil-teacher ratio(headcount basis) of Latin America(all income levels) in 2008 to that in 2011?
Provide a succinct answer. 1.04. What is the ratio of the Pupil-teacher ratio(headcount basis) in Bhutan in 2008 to that in 2011?
Ensure brevity in your answer.  1.16. What is the ratio of the Pupil-teacher ratio(headcount basis) of Tonga in 2008 to that in 2011?
Ensure brevity in your answer.  1.02. What is the ratio of the Pupil-teacher ratio(headcount basis) of East Asia (developing only) in 2009 to that in 2010?
Keep it short and to the point. 1.02. What is the ratio of the Pupil-teacher ratio(headcount basis) in Latin America(all income levels) in 2009 to that in 2010?
Your answer should be very brief. 1.02. What is the ratio of the Pupil-teacher ratio(headcount basis) in Bhutan in 2009 to that in 2010?
Provide a succinct answer. 0.96. What is the ratio of the Pupil-teacher ratio(headcount basis) of Tonga in 2009 to that in 2010?
Offer a very short reply. 1.01. What is the ratio of the Pupil-teacher ratio(headcount basis) of East Asia (developing only) in 2009 to that in 2011?
Offer a terse response. 1.01. What is the ratio of the Pupil-teacher ratio(headcount basis) in Latin America(all income levels) in 2009 to that in 2011?
Your answer should be very brief. 1.03. What is the ratio of the Pupil-teacher ratio(headcount basis) in Bhutan in 2009 to that in 2011?
Offer a terse response. 1.01. What is the ratio of the Pupil-teacher ratio(headcount basis) of Tonga in 2009 to that in 2011?
Ensure brevity in your answer.  1.03. What is the ratio of the Pupil-teacher ratio(headcount basis) of East Asia (developing only) in 2010 to that in 2011?
Your response must be concise. 0.99. What is the ratio of the Pupil-teacher ratio(headcount basis) of Latin America(all income levels) in 2010 to that in 2011?
Your answer should be very brief. 1.01. What is the ratio of the Pupil-teacher ratio(headcount basis) in Bhutan in 2010 to that in 2011?
Your response must be concise. 1.04. What is the ratio of the Pupil-teacher ratio(headcount basis) of Tonga in 2010 to that in 2011?
Provide a short and direct response. 1.02. What is the difference between the highest and the second highest Pupil-teacher ratio(headcount basis) in East Asia (developing only)?
Offer a terse response. 0.08. What is the difference between the highest and the second highest Pupil-teacher ratio(headcount basis) in Latin America(all income levels)?
Your answer should be compact. 1.54. What is the difference between the highest and the second highest Pupil-teacher ratio(headcount basis) in Bhutan?
Offer a very short reply. 7.33. What is the difference between the highest and the second highest Pupil-teacher ratio(headcount basis) in Tonga?
Offer a terse response. 4.98. What is the difference between the highest and the lowest Pupil-teacher ratio(headcount basis) of East Asia (developing only)?
Ensure brevity in your answer.  1.45. What is the difference between the highest and the lowest Pupil-teacher ratio(headcount basis) in Latin America(all income levels)?
Provide a succinct answer. 2.19. What is the difference between the highest and the lowest Pupil-teacher ratio(headcount basis) of Bhutan?
Keep it short and to the point. 20.97. What is the difference between the highest and the lowest Pupil-teacher ratio(headcount basis) of Tonga?
Offer a very short reply. 5.37. 